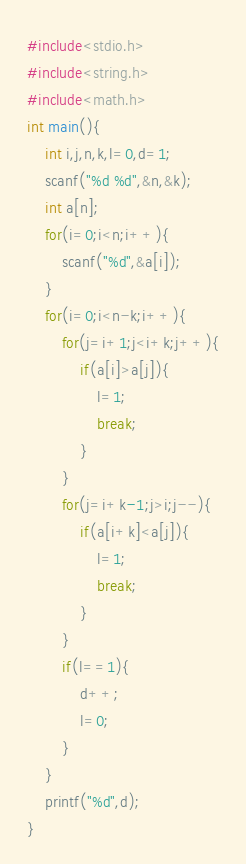Convert code to text. <code><loc_0><loc_0><loc_500><loc_500><_C++_>#include<stdio.h>
#include<string.h>
#include<math.h>
int main(){
    int i,j,n,k,l=0,d=1;
    scanf("%d %d",&n,&k);
    int a[n];
    for(i=0;i<n;i++){
        scanf("%d",&a[i]);
    }
    for(i=0;i<n-k;i++){
        for(j=i+1;j<i+k;j++){
            if(a[i]>a[j]){
                l=1;
                break;
            }
        }
        for(j=i+k-1;j>i;j--){
            if(a[i+k]<a[j]){
                l=1;
                break;
            }
        }
        if(l==1){
            d++;
            l=0;
        }
    }
    printf("%d",d);
}</code> 